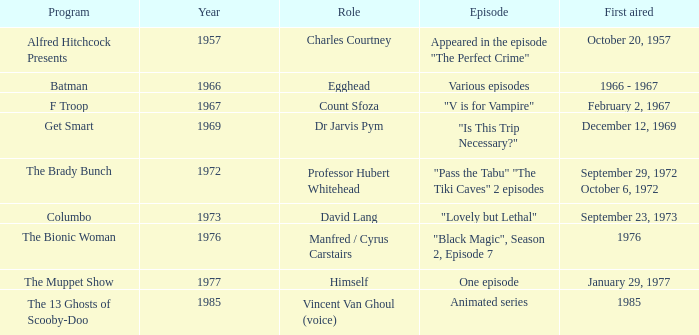What episode was first aired in 1976? "Black Magic", Season 2, Episode 7. 